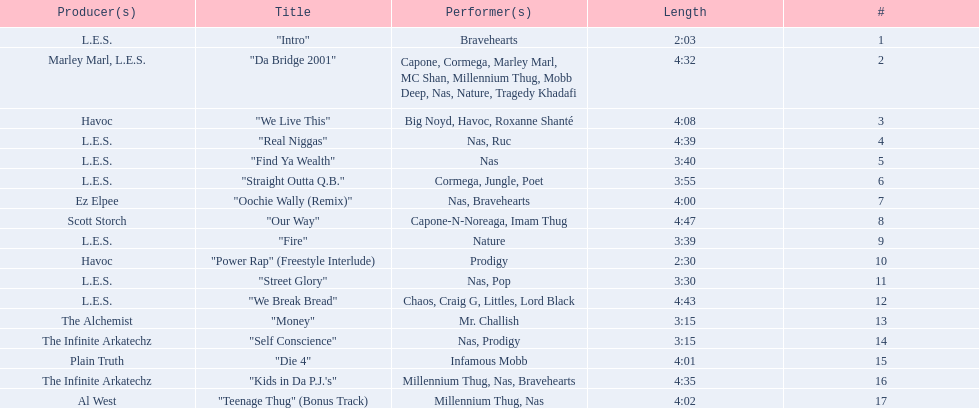How long is each song? 2:03, 4:32, 4:08, 4:39, 3:40, 3:55, 4:00, 4:47, 3:39, 2:30, 3:30, 4:43, 3:15, 3:15, 4:01, 4:35, 4:02. Of those, which length is the shortest? 2:03. 